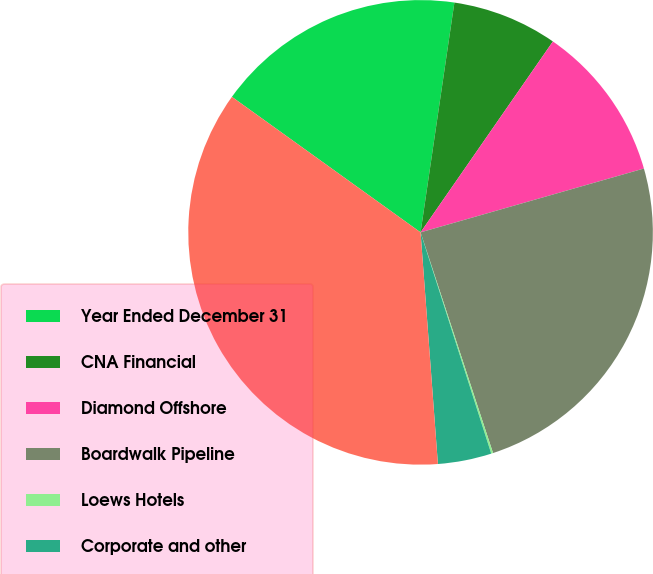Convert chart. <chart><loc_0><loc_0><loc_500><loc_500><pie_chart><fcel>Year Ended December 31<fcel>CNA Financial<fcel>Diamond Offshore<fcel>Boardwalk Pipeline<fcel>Loews Hotels<fcel>Corporate and other<fcel>Total<nl><fcel>17.41%<fcel>7.32%<fcel>10.92%<fcel>24.38%<fcel>0.13%<fcel>3.73%<fcel>36.1%<nl></chart> 